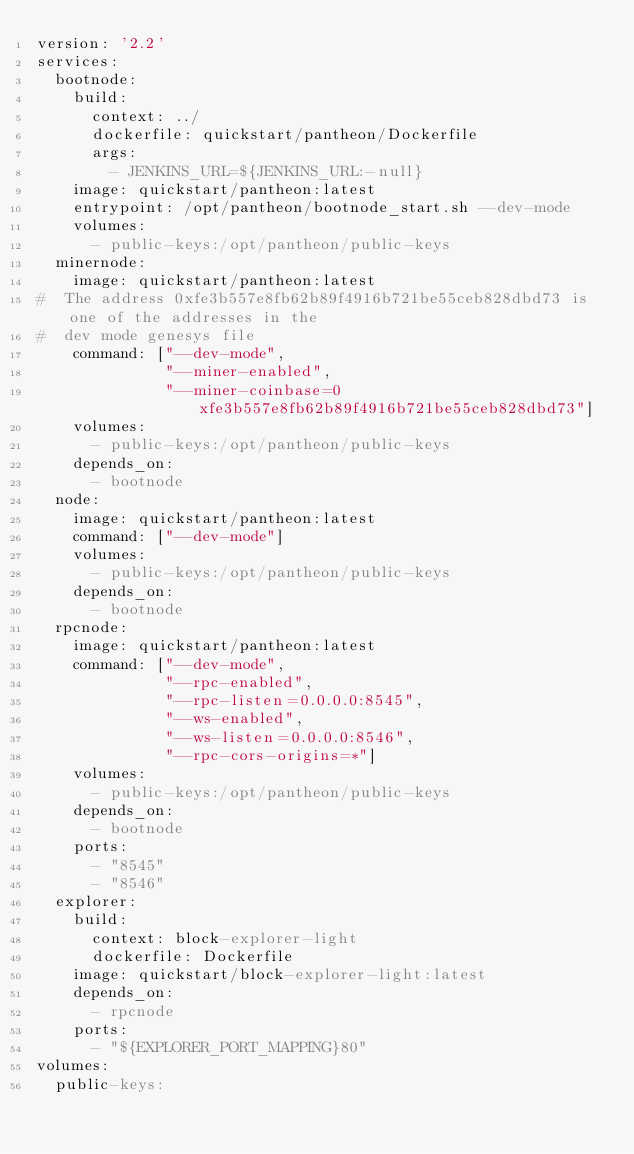<code> <loc_0><loc_0><loc_500><loc_500><_YAML_>version: '2.2'
services:
  bootnode:
    build:
      context: ../
      dockerfile: quickstart/pantheon/Dockerfile
      args:
        - JENKINS_URL=${JENKINS_URL:-null}
    image: quickstart/pantheon:latest
    entrypoint: /opt/pantheon/bootnode_start.sh --dev-mode
    volumes:
      - public-keys:/opt/pantheon/public-keys
  minernode:
    image: quickstart/pantheon:latest
#  The address 0xfe3b557e8fb62b89f4916b721be55ceb828dbd73 is one of the addresses in the
#  dev mode genesys file
    command: ["--dev-mode",
              "--miner-enabled",
              "--miner-coinbase=0xfe3b557e8fb62b89f4916b721be55ceb828dbd73"]
    volumes:
      - public-keys:/opt/pantheon/public-keys
    depends_on:
      - bootnode
  node:
    image: quickstart/pantheon:latest
    command: ["--dev-mode"]
    volumes:
      - public-keys:/opt/pantheon/public-keys
    depends_on:
      - bootnode
  rpcnode:
    image: quickstart/pantheon:latest
    command: ["--dev-mode",
              "--rpc-enabled",
              "--rpc-listen=0.0.0.0:8545",
              "--ws-enabled",
              "--ws-listen=0.0.0.0:8546",
              "--rpc-cors-origins=*"]
    volumes:
      - public-keys:/opt/pantheon/public-keys
    depends_on:
      - bootnode
    ports:
      - "8545"
      - "8546"
  explorer:
    build:
      context: block-explorer-light
      dockerfile: Dockerfile
    image: quickstart/block-explorer-light:latest
    depends_on:
      - rpcnode
    ports:
      - "${EXPLORER_PORT_MAPPING}80"
volumes:
  public-keys:
</code> 